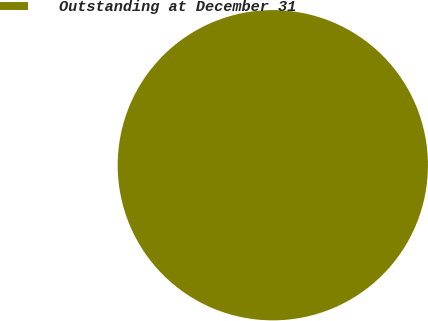Convert chart. <chart><loc_0><loc_0><loc_500><loc_500><pie_chart><fcel>Outstanding at December 31<nl><fcel>100.0%<nl></chart> 